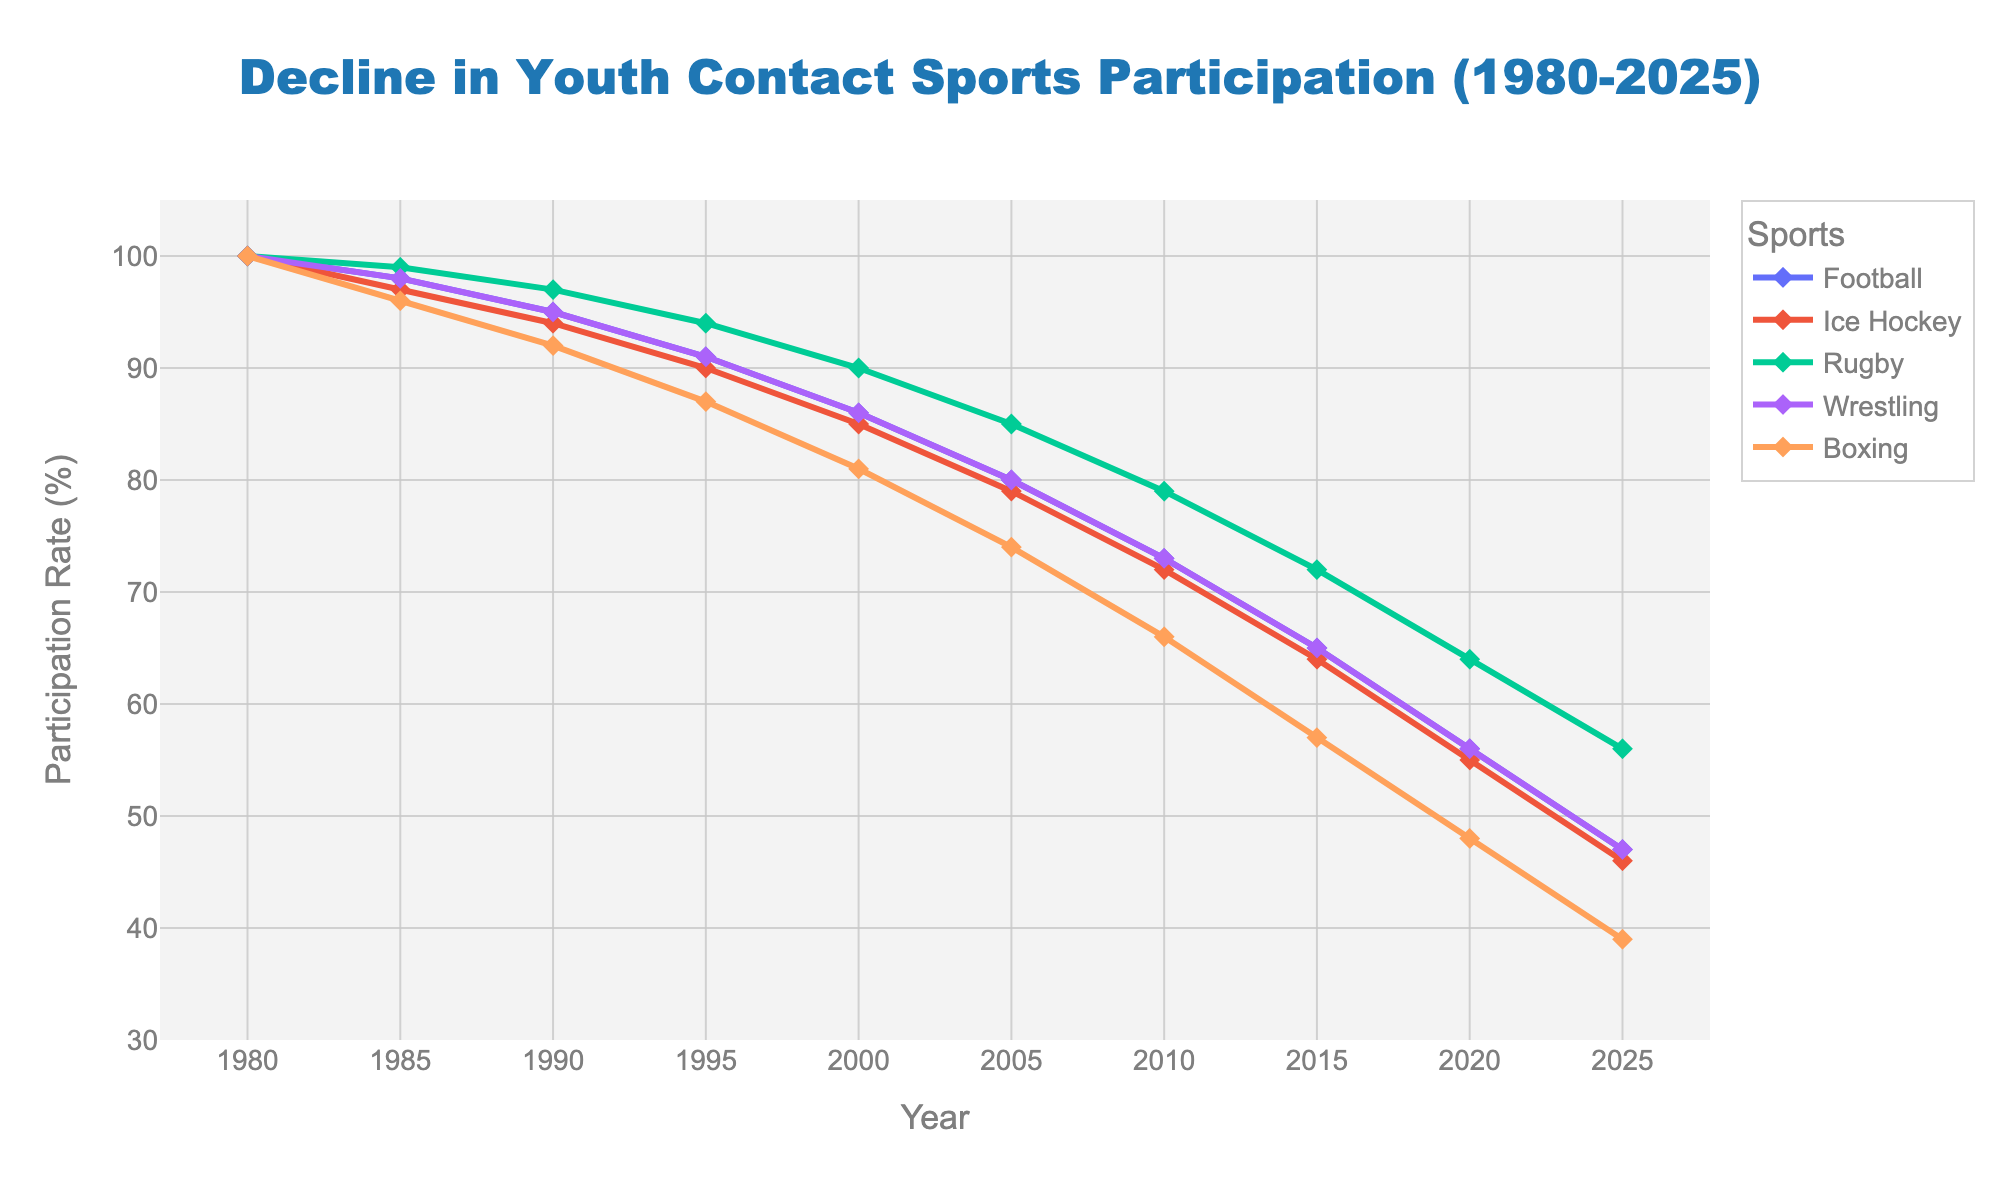What's the participation rate for Football in 2025 compared to 1985? The participation rate for Football in 2025 is 47%, and in 1985 it is 98%. The comparison shows that the participation rate in 2025 is significantly lower than in 1985.
Answer: 47% in 2025, 98% in 1985 Which sport had the steepest decline in participation rate from 1980 to 2025? To determine the steepest decline, we look at the difference in participation rates from 1980 to 2025 for each sport. The greatest difference is in Boxing (100% in 1980 to 39% in 2025), with a decline of 61 percentage points.
Answer: Boxing What is the average decline in participation rates for Ice Hockey from 1980 to 2025? In 1980, the participation rate for Ice Hockey is 100%. In 2025, it is 46%. The decline is 100% - 46% = 54%. The average decline over the 45-year period is 54% / 45 = 1.2% per year.
Answer: 1.2% per year By how many percentage points did Rugby's participation rate decrease from 2000 to 2020? In 2000, Rugby’s participation rate is 90%. In 2020, it is 64%. The decrease is 90% - 64% = 26 percentage points.
Answer: 26 percentage points What can you say about the trend in Wrestling participation rates between 1980 and 2025? The participation rate for Wrestling starts at 100% in 1980 and decreases progressively each decade, ending at 47% in 2025. It shows a consistent downward trend over the years.
Answer: Consistent downward trend How does the participation rate for Boxing in 2010 compare to that of Wrestling in 2010? In 2010, the participation rate for Boxing is 66%, while for Wrestling, it is 73%. Therefore, Wrestling has a higher participation rate than Boxing in 2010.
Answer: Wrestling has a higher rate What year saw a drop in Rugby participation rate below 80% for the first time? By examining the data, Rugby's participation rate drops below 80% for the first time in the year 2010 when it reaches 79%.
Answer: 2010 What is the difference in participation rates between Football and Ice Hockey in 2020? In 2020, the participation rate for Football is 56%, and for Ice Hockey, it is 55%. The difference is 56% - 55% = 1 percentage point.
Answer: 1 percentage point When did Football's participation rate first fall below 90%? Football’s participation rate falls below 90% for the first time in 1995 when it reaches 91%.
Answer: 1995 Which year had the smallest difference in participation rates between Rugby and Boxing? To find the smallest difference, we compare the participation rates for Rugby and Boxing for each year. In 2000, Rugby has a rate of 90% and Boxing has 81%, making the difference 9 percentage points, which is the smallest.
Answer: 2000 